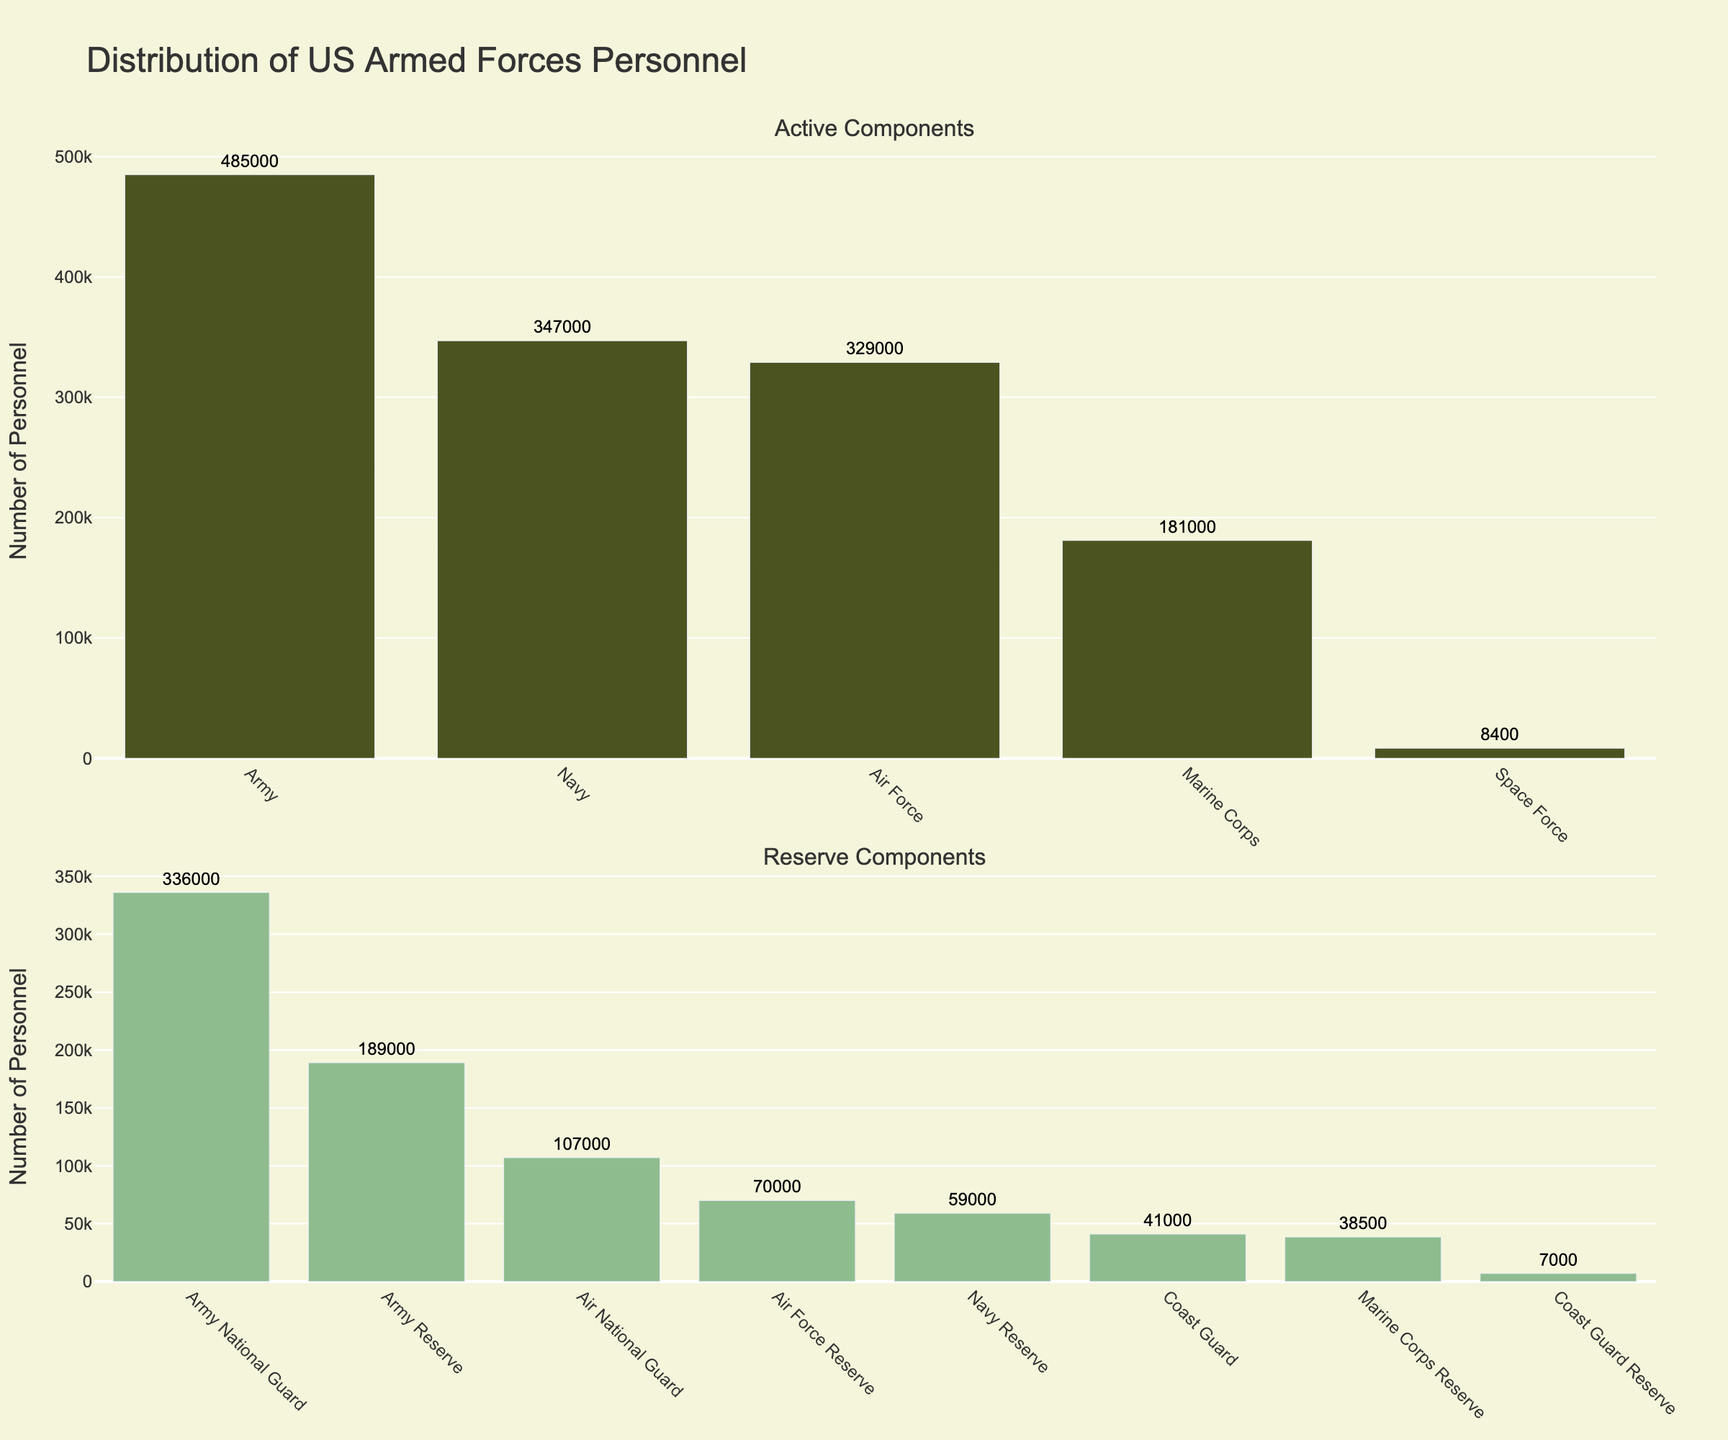Which branch has the highest number of active personnel? The Army has the tallest bar among the active components, indicating it has the highest number of personnel.
Answer: Army What is the total number of personnel in the Reserve components? Sum the number of personnel in each Reserve component: Army National Guard (336,000) + Air National Guard (107,000) + Army Reserve (189,000) + Navy Reserve (59,000) + Marine Corps Reserve (38,500) + Air Force Reserve (70,000) + Coast Guard Reserve (7,000). The total is 807,500.
Answer: 807,500 Compare the personnel in the Marine Corps and the Marine Corps Reserve. Which one has more personnel and by how much? The Marine Corps has 181,000 personnel and the Marine Corps Reserve has 38,500 personnel. The difference is 181,000 - 38,500 = 142,500. The Marine Corps has 142,500 more personnel.
Answer: Marine Corps by 142,500 What's the ratio of active Coast Guard personnel to Coast Guard Reserve personnel? The number of active Coast Guard personnel is 41,000, and the number of Coast Guard Reserve personnel is 7,000. The ratio is 41,000 to 7,000, or simplified, approximately 5.86 to 1.
Answer: 5.86:1 How many more personnel does the Navy have compared to the Air Force? The Navy has 347,000 personnel, and the Air Force has 329,000 personnel. The difference is 347,000 - 329,000 = 18,000.
Answer: 18,000 What is the average number of personnel in the active branches (excluding reserves and guards)? Sum the personnel in the active branches (Army, Navy, Air Force, Marine Corps, Coast Guard, Space Force), then divide by the number of branches: (485,000 + 347,000 + 329,000 + 181,000 + 41,000 + 8,400) / 6 = 1,391,400 / 6 ≈ 231,900.
Answer: 231,900 Which component has the least number of personnel? The bar for the Space Force is the shortest, indicating it has the least number of personnel.
Answer: Space Force Is the number of personnel in the Army National Guard greater than that of the Air National Guard by a factor of more than 3? The Army National Guard has 336,000 personnel, and the Air National Guard has 107,000. The ratio is 336,000 / 107,000 ≈ 3.14, which is more than 3.
Answer: Yes, by a factor of approximately 3.14 What is the combined number of personnel in the Army and Army Reserve? Add the personnel in the Army (485,000) and the Army Reserve (189,000): 485,000 + 189,000 = 674,000.
Answer: 674,000 